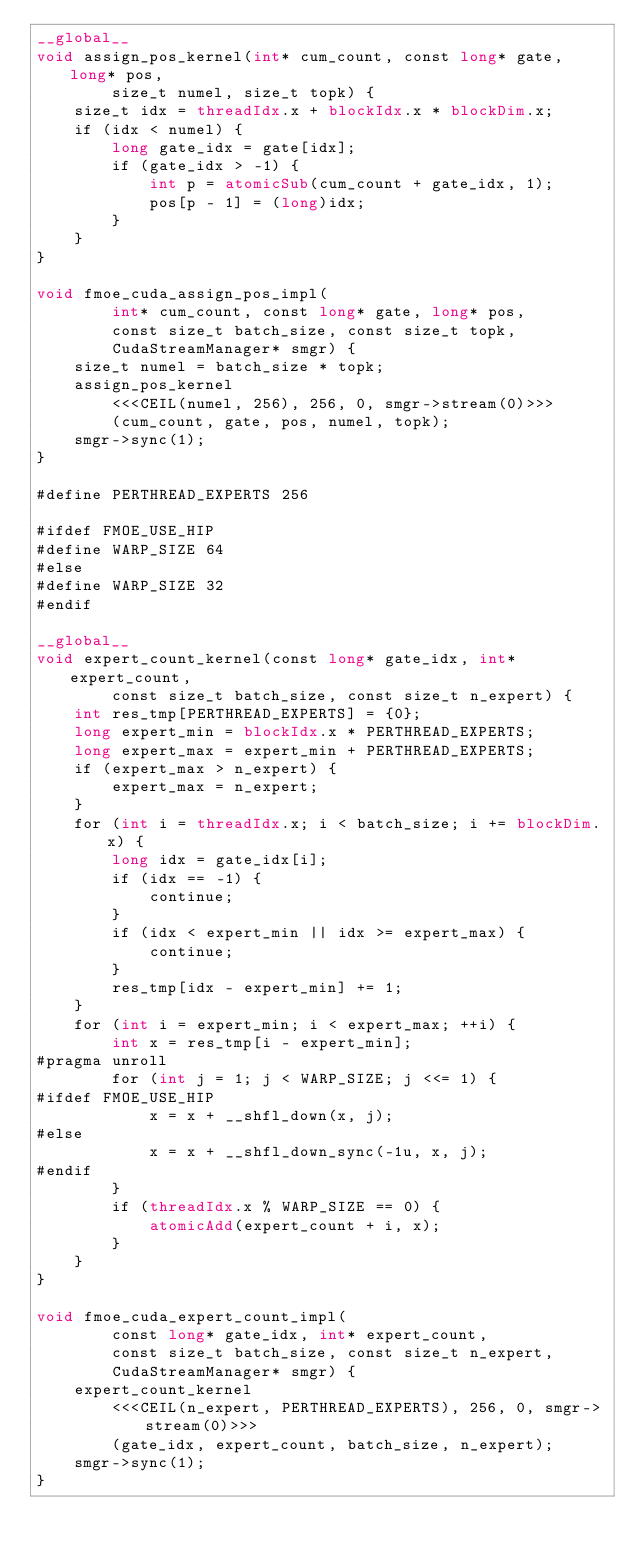<code> <loc_0><loc_0><loc_500><loc_500><_Cuda_>__global__
void assign_pos_kernel(int* cum_count, const long* gate, long* pos,
        size_t numel, size_t topk) {
    size_t idx = threadIdx.x + blockIdx.x * blockDim.x;
    if (idx < numel) {
        long gate_idx = gate[idx];
        if (gate_idx > -1) {
            int p = atomicSub(cum_count + gate_idx, 1);
            pos[p - 1] = (long)idx;
        }
    }
}

void fmoe_cuda_assign_pos_impl(
        int* cum_count, const long* gate, long* pos,
        const size_t batch_size, const size_t topk,
        CudaStreamManager* smgr) {
    size_t numel = batch_size * topk;
    assign_pos_kernel
        <<<CEIL(numel, 256), 256, 0, smgr->stream(0)>>>
        (cum_count, gate, pos, numel, topk);
    smgr->sync(1);
}

#define PERTHREAD_EXPERTS 256

#ifdef FMOE_USE_HIP
#define WARP_SIZE 64
#else
#define WARP_SIZE 32
#endif

__global__
void expert_count_kernel(const long* gate_idx, int* expert_count,
        const size_t batch_size, const size_t n_expert) {
    int res_tmp[PERTHREAD_EXPERTS] = {0};
    long expert_min = blockIdx.x * PERTHREAD_EXPERTS;
    long expert_max = expert_min + PERTHREAD_EXPERTS;
    if (expert_max > n_expert) {
        expert_max = n_expert;
    }
    for (int i = threadIdx.x; i < batch_size; i += blockDim.x) {
        long idx = gate_idx[i];
        if (idx == -1) {
            continue;
        }
        if (idx < expert_min || idx >= expert_max) {
            continue;
        }
        res_tmp[idx - expert_min] += 1;
    }
    for (int i = expert_min; i < expert_max; ++i) {
        int x = res_tmp[i - expert_min];
#pragma unroll
        for (int j = 1; j < WARP_SIZE; j <<= 1) {
#ifdef FMOE_USE_HIP
            x = x + __shfl_down(x, j);
#else
            x = x + __shfl_down_sync(-1u, x, j);
#endif
        }
        if (threadIdx.x % WARP_SIZE == 0) {
            atomicAdd(expert_count + i, x);
        }
    }
}

void fmoe_cuda_expert_count_impl(
        const long* gate_idx, int* expert_count,
        const size_t batch_size, const size_t n_expert,
        CudaStreamManager* smgr) {
    expert_count_kernel
        <<<CEIL(n_expert, PERTHREAD_EXPERTS), 256, 0, smgr->stream(0)>>>
        (gate_idx, expert_count, batch_size, n_expert);
    smgr->sync(1);
}
</code> 